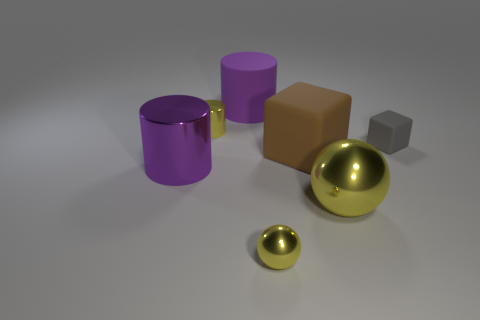How big is the purple cylinder that is behind the big metallic object left of the big purple cylinder on the right side of the yellow metallic cylinder?
Offer a terse response. Large. There is a purple rubber thing; does it have the same shape as the purple object that is in front of the tiny rubber thing?
Offer a terse response. Yes. Are there any other cylinders of the same color as the matte cylinder?
Your answer should be compact. Yes. What number of balls are either large cyan metallic things or small metallic things?
Offer a terse response. 1. Is there another rubber thing of the same shape as the big purple matte object?
Give a very brief answer. No. What number of other objects are there of the same color as the large metallic sphere?
Keep it short and to the point. 2. Is the number of purple rubber cylinders that are in front of the large yellow metallic sphere less than the number of small red cylinders?
Your answer should be compact. No. What number of big matte cylinders are there?
Provide a short and direct response. 1. How many tiny objects are the same material as the large brown thing?
Provide a short and direct response. 1. What number of things are small yellow objects that are behind the big matte block or yellow balls?
Your answer should be very brief. 3. 